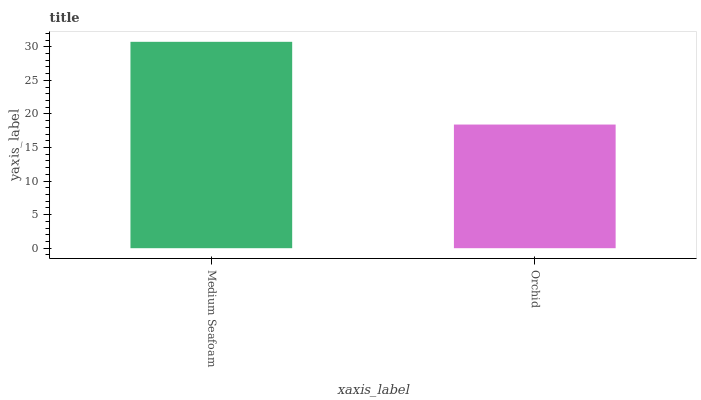Is Orchid the maximum?
Answer yes or no. No. Is Medium Seafoam greater than Orchid?
Answer yes or no. Yes. Is Orchid less than Medium Seafoam?
Answer yes or no. Yes. Is Orchid greater than Medium Seafoam?
Answer yes or no. No. Is Medium Seafoam less than Orchid?
Answer yes or no. No. Is Medium Seafoam the high median?
Answer yes or no. Yes. Is Orchid the low median?
Answer yes or no. Yes. Is Orchid the high median?
Answer yes or no. No. Is Medium Seafoam the low median?
Answer yes or no. No. 